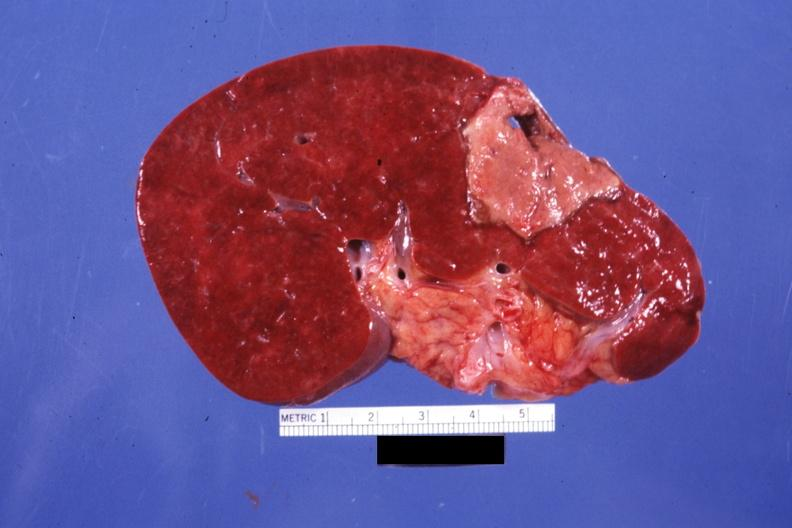what does this image show?
Answer the question using a single word or phrase. Large and typically shaped old infarct but far from fibrotic 